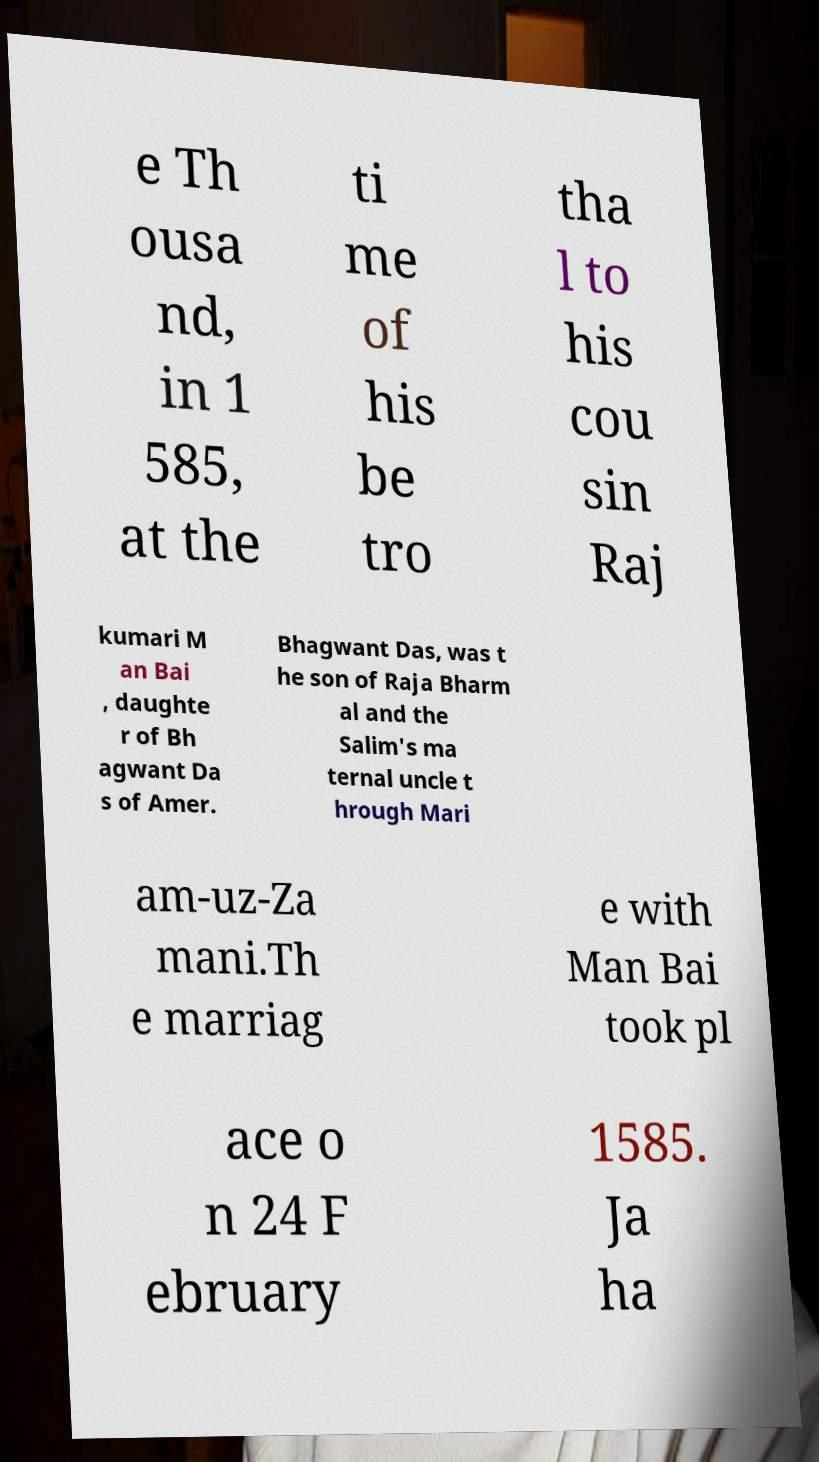Please read and relay the text visible in this image. What does it say? e Th ousa nd, in 1 585, at the ti me of his be tro tha l to his cou sin Raj kumari M an Bai , daughte r of Bh agwant Da s of Amer. Bhagwant Das, was t he son of Raja Bharm al and the Salim's ma ternal uncle t hrough Mari am-uz-Za mani.Th e marriag e with Man Bai took pl ace o n 24 F ebruary 1585. Ja ha 